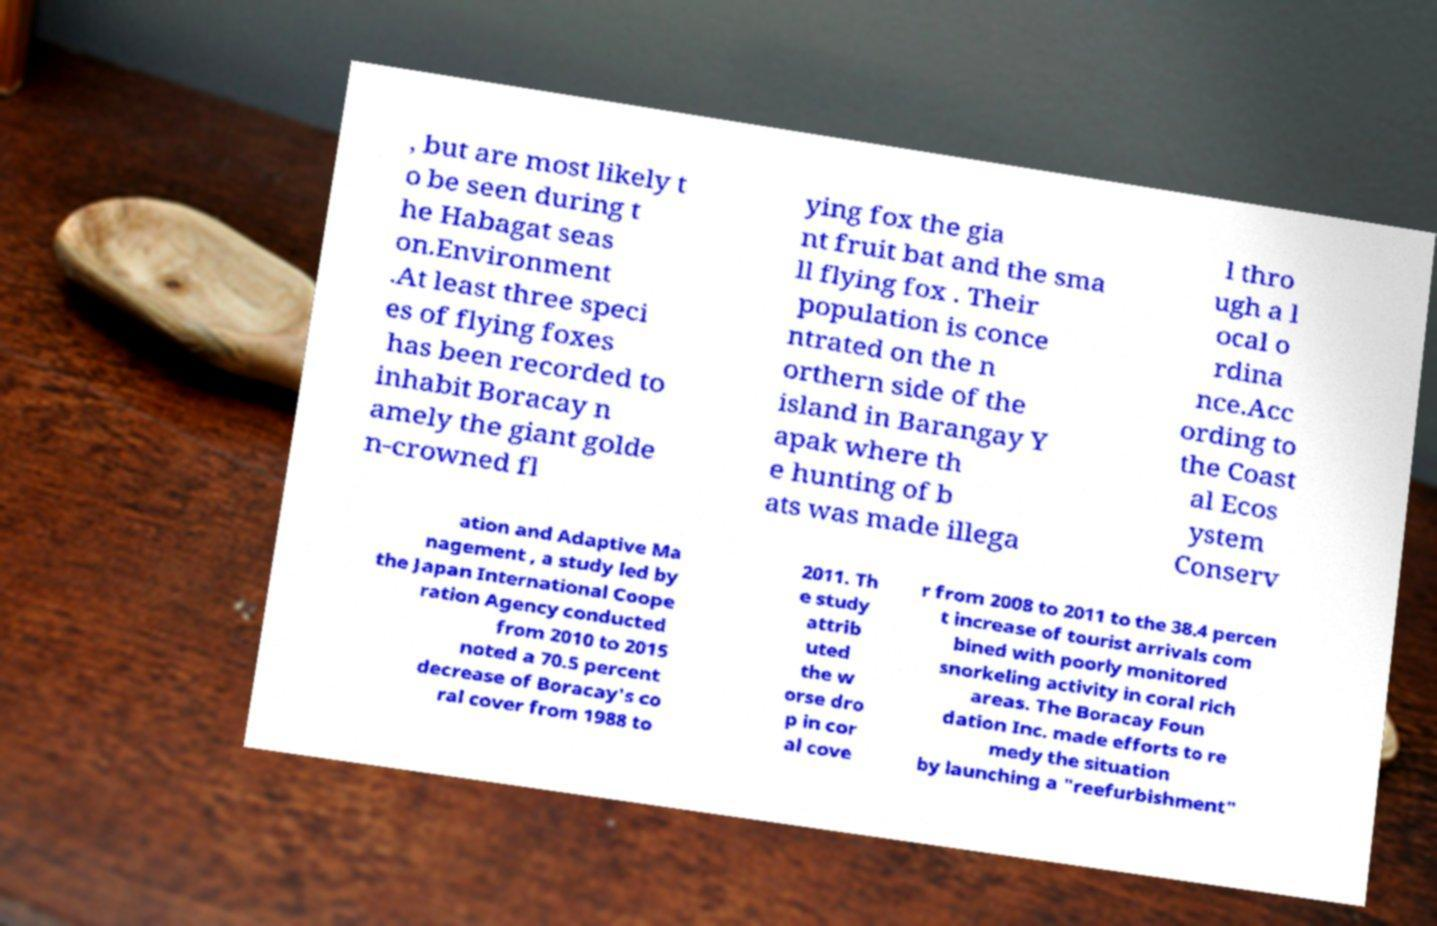For documentation purposes, I need the text within this image transcribed. Could you provide that? , but are most likely t o be seen during t he Habagat seas on.Environment .At least three speci es of flying foxes has been recorded to inhabit Boracay n amely the giant golde n-crowned fl ying fox the gia nt fruit bat and the sma ll flying fox . Their population is conce ntrated on the n orthern side of the island in Barangay Y apak where th e hunting of b ats was made illega l thro ugh a l ocal o rdina nce.Acc ording to the Coast al Ecos ystem Conserv ation and Adaptive Ma nagement , a study led by the Japan International Coope ration Agency conducted from 2010 to 2015 noted a 70.5 percent decrease of Boracay's co ral cover from 1988 to 2011. Th e study attrib uted the w orse dro p in cor al cove r from 2008 to 2011 to the 38.4 percen t increase of tourist arrivals com bined with poorly monitored snorkeling activity in coral rich areas. The Boracay Foun dation Inc. made efforts to re medy the situation by launching a "reefurbishment" 